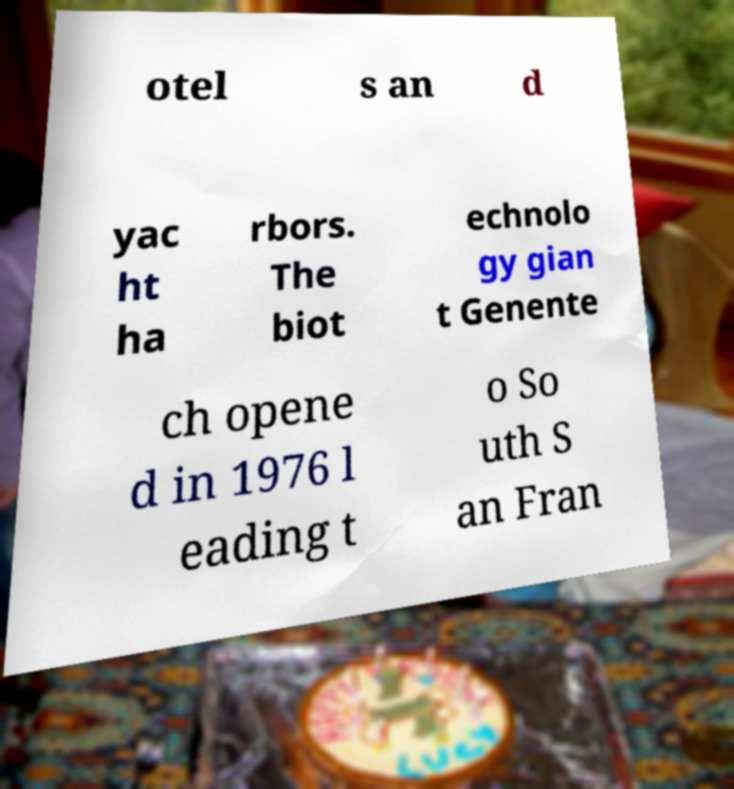I need the written content from this picture converted into text. Can you do that? otel s an d yac ht ha rbors. The biot echnolo gy gian t Genente ch opene d in 1976 l eading t o So uth S an Fran 